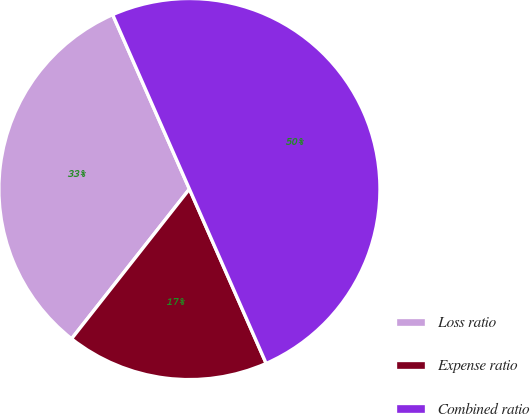Convert chart to OTSL. <chart><loc_0><loc_0><loc_500><loc_500><pie_chart><fcel>Loss ratio<fcel>Expense ratio<fcel>Combined ratio<nl><fcel>32.79%<fcel>17.21%<fcel>50.0%<nl></chart> 